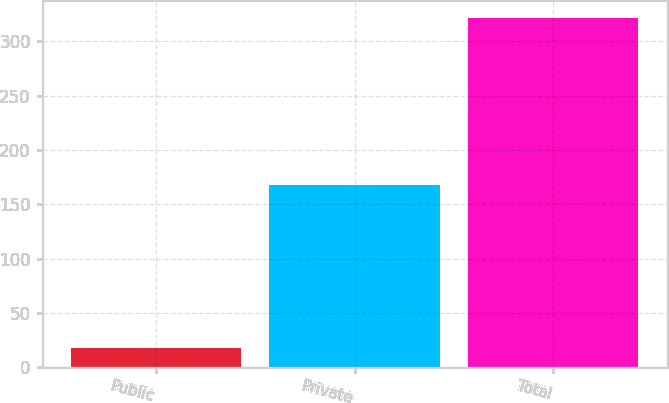Convert chart to OTSL. <chart><loc_0><loc_0><loc_500><loc_500><bar_chart><fcel>Public<fcel>Private<fcel>Total<nl><fcel>18<fcel>168<fcel>321<nl></chart> 